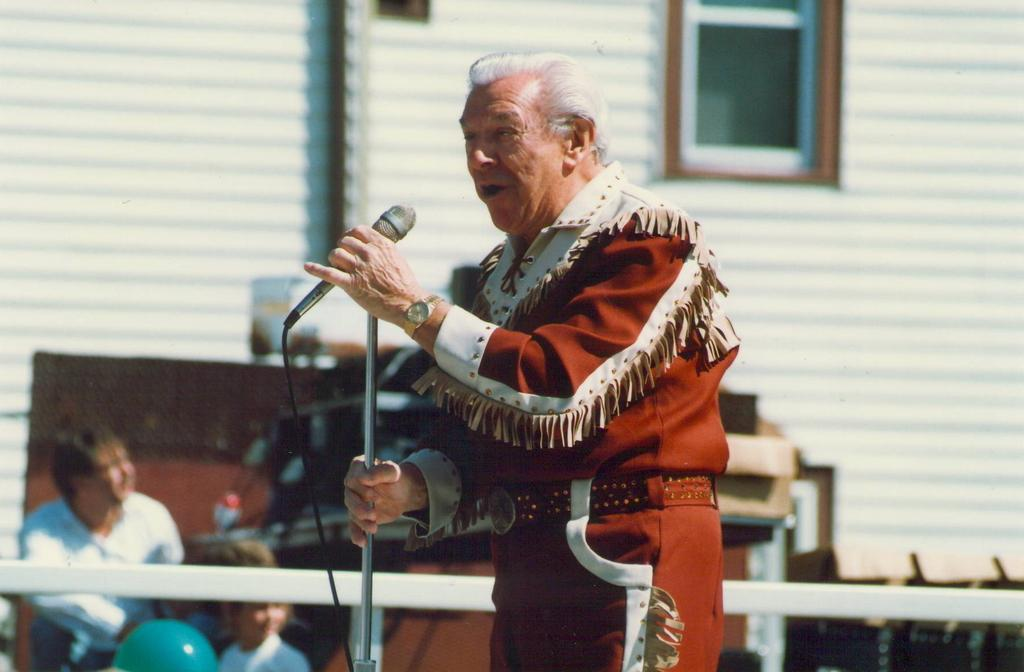What is the man in the image doing? The man is standing and holding a mic in the image. Who else is present in the image besides the man? There is a person and a girl to the right of the man. What can be seen in the background of the image? There is a green balloon and a wooden desk in the background. What type of stamp is on the man's forehead in the image? There is no stamp on the man's forehead in the image. 